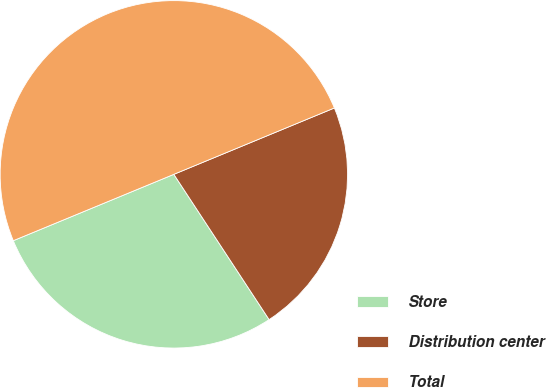<chart> <loc_0><loc_0><loc_500><loc_500><pie_chart><fcel>Store<fcel>Distribution center<fcel>Total<nl><fcel>28.0%<fcel>22.0%<fcel>50.0%<nl></chart> 